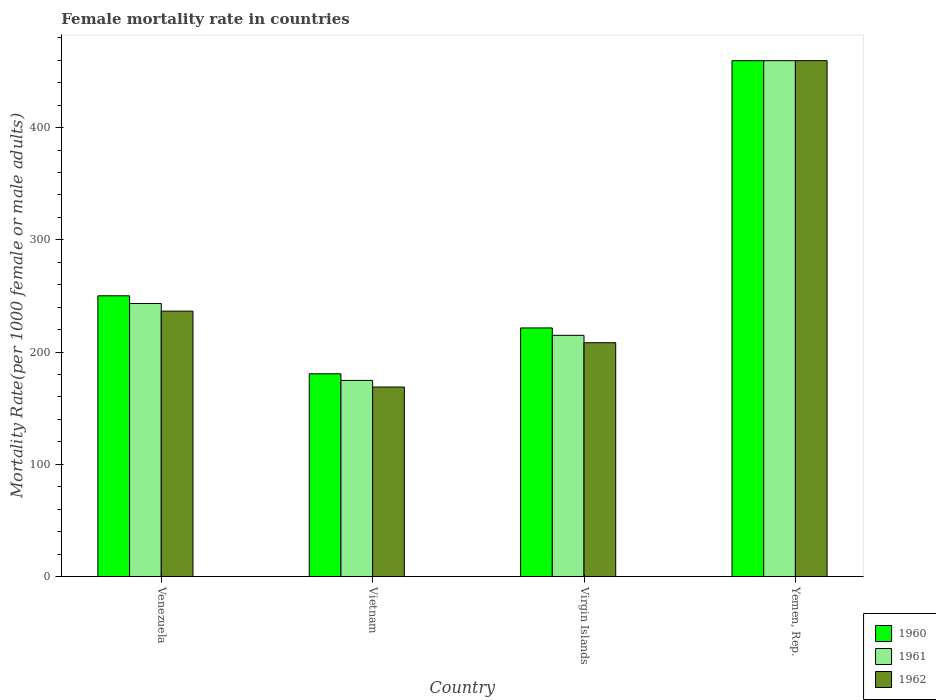How many different coloured bars are there?
Your response must be concise. 3. Are the number of bars per tick equal to the number of legend labels?
Ensure brevity in your answer.  Yes. Are the number of bars on each tick of the X-axis equal?
Your answer should be very brief. Yes. How many bars are there on the 1st tick from the left?
Keep it short and to the point. 3. What is the label of the 2nd group of bars from the left?
Give a very brief answer. Vietnam. In how many cases, is the number of bars for a given country not equal to the number of legend labels?
Keep it short and to the point. 0. What is the female mortality rate in 1961 in Virgin Islands?
Keep it short and to the point. 214.88. Across all countries, what is the maximum female mortality rate in 1962?
Offer a very short reply. 459.63. Across all countries, what is the minimum female mortality rate in 1962?
Your response must be concise. 168.82. In which country was the female mortality rate in 1961 maximum?
Provide a succinct answer. Yemen, Rep. In which country was the female mortality rate in 1961 minimum?
Ensure brevity in your answer.  Vietnam. What is the total female mortality rate in 1962 in the graph?
Give a very brief answer. 1073.21. What is the difference between the female mortality rate in 1962 in Vietnam and that in Yemen, Rep.?
Provide a short and direct response. -290.81. What is the difference between the female mortality rate in 1961 in Yemen, Rep. and the female mortality rate in 1962 in Venezuela?
Keep it short and to the point. 223.17. What is the average female mortality rate in 1961 per country?
Offer a very short reply. 273.13. What is the difference between the female mortality rate of/in 1960 and female mortality rate of/in 1961 in Vietnam?
Your answer should be compact. 5.89. In how many countries, is the female mortality rate in 1961 greater than 420?
Keep it short and to the point. 1. What is the ratio of the female mortality rate in 1961 in Vietnam to that in Virgin Islands?
Make the answer very short. 0.81. Is the difference between the female mortality rate in 1960 in Virgin Islands and Yemen, Rep. greater than the difference between the female mortality rate in 1961 in Virgin Islands and Yemen, Rep.?
Offer a terse response. Yes. What is the difference between the highest and the second highest female mortality rate in 1960?
Give a very brief answer. -209.51. What is the difference between the highest and the lowest female mortality rate in 1961?
Keep it short and to the point. 284.92. In how many countries, is the female mortality rate in 1962 greater than the average female mortality rate in 1962 taken over all countries?
Make the answer very short. 1. What does the 3rd bar from the left in Virgin Islands represents?
Ensure brevity in your answer.  1962. What does the 2nd bar from the right in Venezuela represents?
Your answer should be compact. 1961. How many bars are there?
Your answer should be very brief. 12. Are all the bars in the graph horizontal?
Your answer should be very brief. No. How many countries are there in the graph?
Provide a short and direct response. 4. Does the graph contain any zero values?
Keep it short and to the point. No. Does the graph contain grids?
Your response must be concise. No. What is the title of the graph?
Your answer should be very brief. Female mortality rate in countries. What is the label or title of the X-axis?
Keep it short and to the point. Country. What is the label or title of the Y-axis?
Your answer should be compact. Mortality Rate(per 1000 female or male adults). What is the Mortality Rate(per 1000 female or male adults) of 1960 in Venezuela?
Give a very brief answer. 250.12. What is the Mortality Rate(per 1000 female or male adults) in 1961 in Venezuela?
Your answer should be very brief. 243.29. What is the Mortality Rate(per 1000 female or male adults) of 1962 in Venezuela?
Make the answer very short. 236.46. What is the Mortality Rate(per 1000 female or male adults) in 1960 in Vietnam?
Offer a very short reply. 180.6. What is the Mortality Rate(per 1000 female or male adults) of 1961 in Vietnam?
Make the answer very short. 174.71. What is the Mortality Rate(per 1000 female or male adults) in 1962 in Vietnam?
Your response must be concise. 168.82. What is the Mortality Rate(per 1000 female or male adults) in 1960 in Virgin Islands?
Your response must be concise. 221.47. What is the Mortality Rate(per 1000 female or male adults) in 1961 in Virgin Islands?
Your response must be concise. 214.88. What is the Mortality Rate(per 1000 female or male adults) in 1962 in Virgin Islands?
Offer a terse response. 208.29. What is the Mortality Rate(per 1000 female or male adults) of 1960 in Yemen, Rep.?
Offer a very short reply. 459.63. What is the Mortality Rate(per 1000 female or male adults) of 1961 in Yemen, Rep.?
Your response must be concise. 459.63. What is the Mortality Rate(per 1000 female or male adults) in 1962 in Yemen, Rep.?
Give a very brief answer. 459.63. Across all countries, what is the maximum Mortality Rate(per 1000 female or male adults) of 1960?
Keep it short and to the point. 459.63. Across all countries, what is the maximum Mortality Rate(per 1000 female or male adults) of 1961?
Offer a very short reply. 459.63. Across all countries, what is the maximum Mortality Rate(per 1000 female or male adults) of 1962?
Give a very brief answer. 459.63. Across all countries, what is the minimum Mortality Rate(per 1000 female or male adults) of 1960?
Your answer should be very brief. 180.6. Across all countries, what is the minimum Mortality Rate(per 1000 female or male adults) in 1961?
Offer a terse response. 174.71. Across all countries, what is the minimum Mortality Rate(per 1000 female or male adults) of 1962?
Provide a succinct answer. 168.82. What is the total Mortality Rate(per 1000 female or male adults) in 1960 in the graph?
Make the answer very short. 1111.83. What is the total Mortality Rate(per 1000 female or male adults) of 1961 in the graph?
Give a very brief answer. 1092.52. What is the total Mortality Rate(per 1000 female or male adults) in 1962 in the graph?
Your answer should be compact. 1073.21. What is the difference between the Mortality Rate(per 1000 female or male adults) of 1960 in Venezuela and that in Vietnam?
Provide a short and direct response. 69.52. What is the difference between the Mortality Rate(per 1000 female or male adults) in 1961 in Venezuela and that in Vietnam?
Offer a very short reply. 68.58. What is the difference between the Mortality Rate(per 1000 female or male adults) of 1962 in Venezuela and that in Vietnam?
Make the answer very short. 67.64. What is the difference between the Mortality Rate(per 1000 female or male adults) of 1960 in Venezuela and that in Virgin Islands?
Your response must be concise. 28.66. What is the difference between the Mortality Rate(per 1000 female or male adults) of 1961 in Venezuela and that in Virgin Islands?
Your answer should be very brief. 28.41. What is the difference between the Mortality Rate(per 1000 female or male adults) in 1962 in Venezuela and that in Virgin Islands?
Your answer should be compact. 28.17. What is the difference between the Mortality Rate(per 1000 female or male adults) in 1960 in Venezuela and that in Yemen, Rep.?
Your answer should be compact. -209.51. What is the difference between the Mortality Rate(per 1000 female or male adults) of 1961 in Venezuela and that in Yemen, Rep.?
Your answer should be compact. -216.34. What is the difference between the Mortality Rate(per 1000 female or male adults) of 1962 in Venezuela and that in Yemen, Rep.?
Your response must be concise. -223.17. What is the difference between the Mortality Rate(per 1000 female or male adults) of 1960 in Vietnam and that in Virgin Islands?
Offer a very short reply. -40.86. What is the difference between the Mortality Rate(per 1000 female or male adults) of 1961 in Vietnam and that in Virgin Islands?
Your answer should be compact. -40.17. What is the difference between the Mortality Rate(per 1000 female or male adults) of 1962 in Vietnam and that in Virgin Islands?
Your response must be concise. -39.47. What is the difference between the Mortality Rate(per 1000 female or male adults) in 1960 in Vietnam and that in Yemen, Rep.?
Give a very brief answer. -279.03. What is the difference between the Mortality Rate(per 1000 female or male adults) in 1961 in Vietnam and that in Yemen, Rep.?
Offer a terse response. -284.92. What is the difference between the Mortality Rate(per 1000 female or male adults) of 1962 in Vietnam and that in Yemen, Rep.?
Ensure brevity in your answer.  -290.81. What is the difference between the Mortality Rate(per 1000 female or male adults) in 1960 in Virgin Islands and that in Yemen, Rep.?
Your answer should be compact. -238.17. What is the difference between the Mortality Rate(per 1000 female or male adults) of 1961 in Virgin Islands and that in Yemen, Rep.?
Offer a terse response. -244.75. What is the difference between the Mortality Rate(per 1000 female or male adults) of 1962 in Virgin Islands and that in Yemen, Rep.?
Ensure brevity in your answer.  -251.34. What is the difference between the Mortality Rate(per 1000 female or male adults) of 1960 in Venezuela and the Mortality Rate(per 1000 female or male adults) of 1961 in Vietnam?
Offer a very short reply. 75.41. What is the difference between the Mortality Rate(per 1000 female or male adults) of 1960 in Venezuela and the Mortality Rate(per 1000 female or male adults) of 1962 in Vietnam?
Your response must be concise. 81.3. What is the difference between the Mortality Rate(per 1000 female or male adults) of 1961 in Venezuela and the Mortality Rate(per 1000 female or male adults) of 1962 in Vietnam?
Ensure brevity in your answer.  74.47. What is the difference between the Mortality Rate(per 1000 female or male adults) of 1960 in Venezuela and the Mortality Rate(per 1000 female or male adults) of 1961 in Virgin Islands?
Provide a short and direct response. 35.24. What is the difference between the Mortality Rate(per 1000 female or male adults) in 1960 in Venezuela and the Mortality Rate(per 1000 female or male adults) in 1962 in Virgin Islands?
Your response must be concise. 41.83. What is the difference between the Mortality Rate(per 1000 female or male adults) of 1961 in Venezuela and the Mortality Rate(per 1000 female or male adults) of 1962 in Virgin Islands?
Your answer should be compact. 35. What is the difference between the Mortality Rate(per 1000 female or male adults) in 1960 in Venezuela and the Mortality Rate(per 1000 female or male adults) in 1961 in Yemen, Rep.?
Ensure brevity in your answer.  -209.51. What is the difference between the Mortality Rate(per 1000 female or male adults) of 1960 in Venezuela and the Mortality Rate(per 1000 female or male adults) of 1962 in Yemen, Rep.?
Your answer should be compact. -209.51. What is the difference between the Mortality Rate(per 1000 female or male adults) of 1961 in Venezuela and the Mortality Rate(per 1000 female or male adults) of 1962 in Yemen, Rep.?
Keep it short and to the point. -216.34. What is the difference between the Mortality Rate(per 1000 female or male adults) of 1960 in Vietnam and the Mortality Rate(per 1000 female or male adults) of 1961 in Virgin Islands?
Offer a very short reply. -34.28. What is the difference between the Mortality Rate(per 1000 female or male adults) of 1960 in Vietnam and the Mortality Rate(per 1000 female or male adults) of 1962 in Virgin Islands?
Make the answer very short. -27.69. What is the difference between the Mortality Rate(per 1000 female or male adults) of 1961 in Vietnam and the Mortality Rate(per 1000 female or male adults) of 1962 in Virgin Islands?
Offer a terse response. -33.58. What is the difference between the Mortality Rate(per 1000 female or male adults) in 1960 in Vietnam and the Mortality Rate(per 1000 female or male adults) in 1961 in Yemen, Rep.?
Your response must be concise. -279.03. What is the difference between the Mortality Rate(per 1000 female or male adults) in 1960 in Vietnam and the Mortality Rate(per 1000 female or male adults) in 1962 in Yemen, Rep.?
Offer a very short reply. -279.03. What is the difference between the Mortality Rate(per 1000 female or male adults) in 1961 in Vietnam and the Mortality Rate(per 1000 female or male adults) in 1962 in Yemen, Rep.?
Make the answer very short. -284.92. What is the difference between the Mortality Rate(per 1000 female or male adults) in 1960 in Virgin Islands and the Mortality Rate(per 1000 female or male adults) in 1961 in Yemen, Rep.?
Provide a short and direct response. -238.17. What is the difference between the Mortality Rate(per 1000 female or male adults) of 1960 in Virgin Islands and the Mortality Rate(per 1000 female or male adults) of 1962 in Yemen, Rep.?
Offer a very short reply. -238.17. What is the difference between the Mortality Rate(per 1000 female or male adults) in 1961 in Virgin Islands and the Mortality Rate(per 1000 female or male adults) in 1962 in Yemen, Rep.?
Your answer should be compact. -244.75. What is the average Mortality Rate(per 1000 female or male adults) in 1960 per country?
Offer a terse response. 277.96. What is the average Mortality Rate(per 1000 female or male adults) in 1961 per country?
Keep it short and to the point. 273.13. What is the average Mortality Rate(per 1000 female or male adults) of 1962 per country?
Give a very brief answer. 268.3. What is the difference between the Mortality Rate(per 1000 female or male adults) in 1960 and Mortality Rate(per 1000 female or male adults) in 1961 in Venezuela?
Provide a succinct answer. 6.83. What is the difference between the Mortality Rate(per 1000 female or male adults) in 1960 and Mortality Rate(per 1000 female or male adults) in 1962 in Venezuela?
Make the answer very short. 13.66. What is the difference between the Mortality Rate(per 1000 female or male adults) in 1961 and Mortality Rate(per 1000 female or male adults) in 1962 in Venezuela?
Give a very brief answer. 6.83. What is the difference between the Mortality Rate(per 1000 female or male adults) in 1960 and Mortality Rate(per 1000 female or male adults) in 1961 in Vietnam?
Give a very brief answer. 5.89. What is the difference between the Mortality Rate(per 1000 female or male adults) of 1960 and Mortality Rate(per 1000 female or male adults) of 1962 in Vietnam?
Provide a short and direct response. 11.78. What is the difference between the Mortality Rate(per 1000 female or male adults) of 1961 and Mortality Rate(per 1000 female or male adults) of 1962 in Vietnam?
Provide a short and direct response. 5.89. What is the difference between the Mortality Rate(per 1000 female or male adults) in 1960 and Mortality Rate(per 1000 female or male adults) in 1961 in Virgin Islands?
Your response must be concise. 6.59. What is the difference between the Mortality Rate(per 1000 female or male adults) in 1960 and Mortality Rate(per 1000 female or male adults) in 1962 in Virgin Islands?
Offer a terse response. 13.17. What is the difference between the Mortality Rate(per 1000 female or male adults) in 1961 and Mortality Rate(per 1000 female or male adults) in 1962 in Virgin Islands?
Offer a terse response. 6.59. What is the ratio of the Mortality Rate(per 1000 female or male adults) in 1960 in Venezuela to that in Vietnam?
Keep it short and to the point. 1.38. What is the ratio of the Mortality Rate(per 1000 female or male adults) of 1961 in Venezuela to that in Vietnam?
Keep it short and to the point. 1.39. What is the ratio of the Mortality Rate(per 1000 female or male adults) of 1962 in Venezuela to that in Vietnam?
Give a very brief answer. 1.4. What is the ratio of the Mortality Rate(per 1000 female or male adults) in 1960 in Venezuela to that in Virgin Islands?
Give a very brief answer. 1.13. What is the ratio of the Mortality Rate(per 1000 female or male adults) in 1961 in Venezuela to that in Virgin Islands?
Make the answer very short. 1.13. What is the ratio of the Mortality Rate(per 1000 female or male adults) of 1962 in Venezuela to that in Virgin Islands?
Your response must be concise. 1.14. What is the ratio of the Mortality Rate(per 1000 female or male adults) of 1960 in Venezuela to that in Yemen, Rep.?
Offer a terse response. 0.54. What is the ratio of the Mortality Rate(per 1000 female or male adults) of 1961 in Venezuela to that in Yemen, Rep.?
Give a very brief answer. 0.53. What is the ratio of the Mortality Rate(per 1000 female or male adults) in 1962 in Venezuela to that in Yemen, Rep.?
Provide a short and direct response. 0.51. What is the ratio of the Mortality Rate(per 1000 female or male adults) of 1960 in Vietnam to that in Virgin Islands?
Your answer should be compact. 0.82. What is the ratio of the Mortality Rate(per 1000 female or male adults) of 1961 in Vietnam to that in Virgin Islands?
Provide a succinct answer. 0.81. What is the ratio of the Mortality Rate(per 1000 female or male adults) of 1962 in Vietnam to that in Virgin Islands?
Offer a terse response. 0.81. What is the ratio of the Mortality Rate(per 1000 female or male adults) in 1960 in Vietnam to that in Yemen, Rep.?
Provide a short and direct response. 0.39. What is the ratio of the Mortality Rate(per 1000 female or male adults) of 1961 in Vietnam to that in Yemen, Rep.?
Ensure brevity in your answer.  0.38. What is the ratio of the Mortality Rate(per 1000 female or male adults) of 1962 in Vietnam to that in Yemen, Rep.?
Keep it short and to the point. 0.37. What is the ratio of the Mortality Rate(per 1000 female or male adults) in 1960 in Virgin Islands to that in Yemen, Rep.?
Your response must be concise. 0.48. What is the ratio of the Mortality Rate(per 1000 female or male adults) in 1961 in Virgin Islands to that in Yemen, Rep.?
Your response must be concise. 0.47. What is the ratio of the Mortality Rate(per 1000 female or male adults) in 1962 in Virgin Islands to that in Yemen, Rep.?
Provide a succinct answer. 0.45. What is the difference between the highest and the second highest Mortality Rate(per 1000 female or male adults) of 1960?
Keep it short and to the point. 209.51. What is the difference between the highest and the second highest Mortality Rate(per 1000 female or male adults) of 1961?
Your answer should be very brief. 216.34. What is the difference between the highest and the second highest Mortality Rate(per 1000 female or male adults) in 1962?
Keep it short and to the point. 223.17. What is the difference between the highest and the lowest Mortality Rate(per 1000 female or male adults) in 1960?
Ensure brevity in your answer.  279.03. What is the difference between the highest and the lowest Mortality Rate(per 1000 female or male adults) of 1961?
Make the answer very short. 284.92. What is the difference between the highest and the lowest Mortality Rate(per 1000 female or male adults) in 1962?
Make the answer very short. 290.81. 